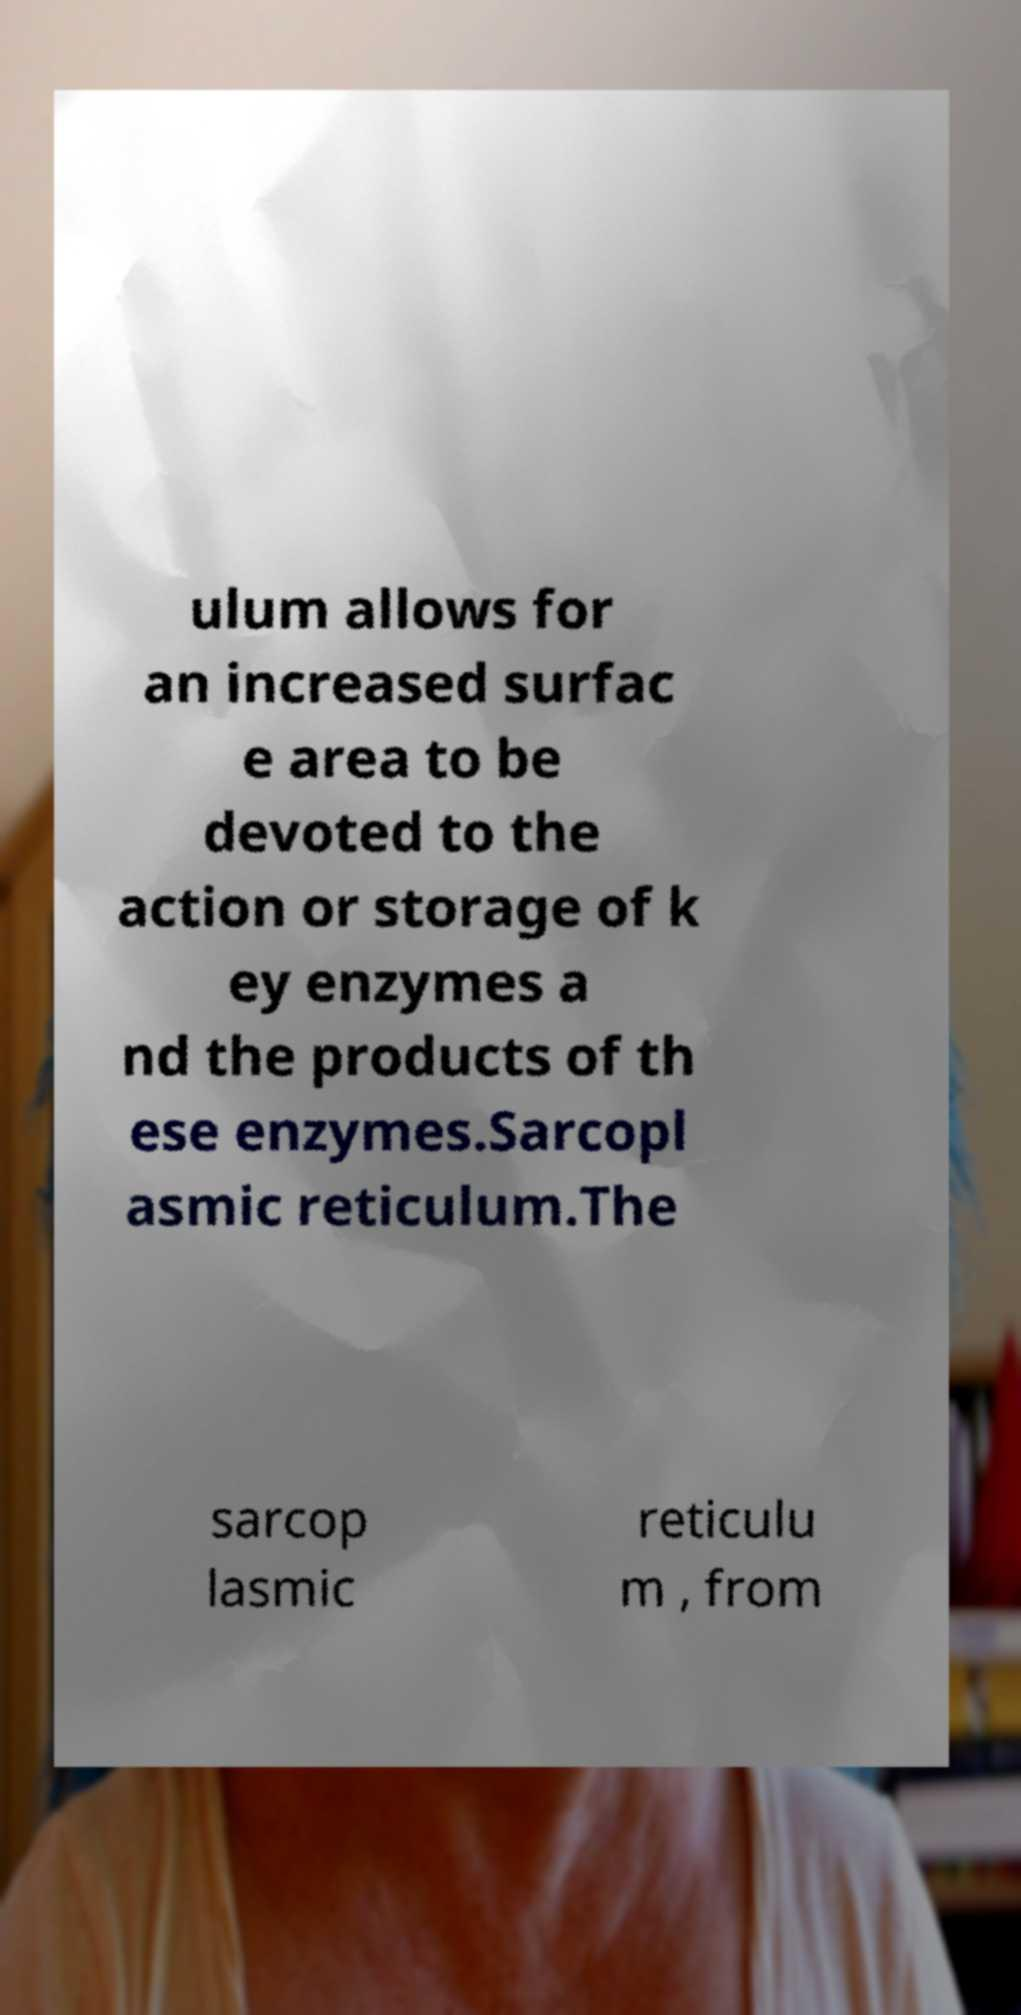There's text embedded in this image that I need extracted. Can you transcribe it verbatim? ulum allows for an increased surfac e area to be devoted to the action or storage of k ey enzymes a nd the products of th ese enzymes.Sarcopl asmic reticulum.The sarcop lasmic reticulu m , from 